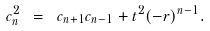Convert formula to latex. <formula><loc_0><loc_0><loc_500><loc_500>c _ { n } ^ { 2 } \ = \ c _ { n + 1 } c _ { n - 1 } + t ^ { 2 } ( - r ) ^ { n - 1 } .</formula> 